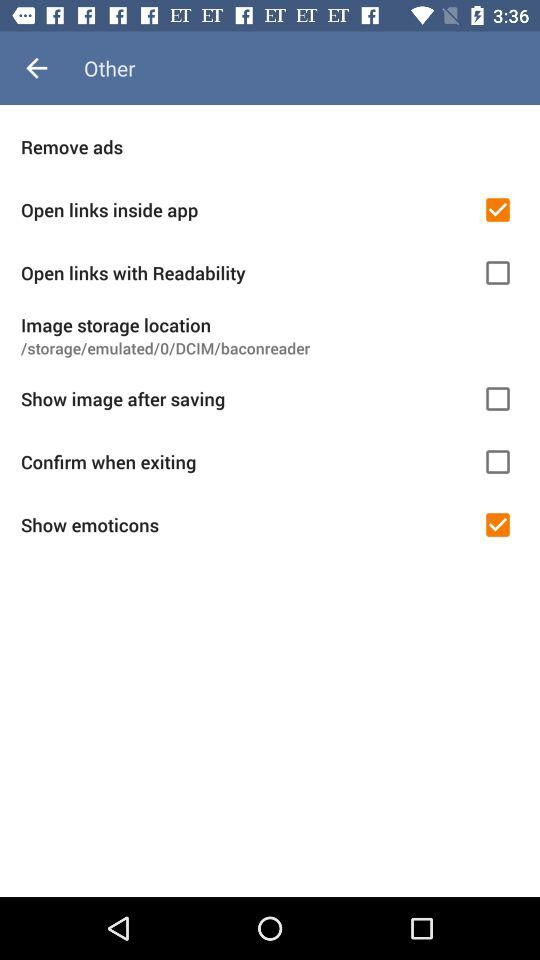What is the current status of "Confirm when exiting"? The current status is "off". 